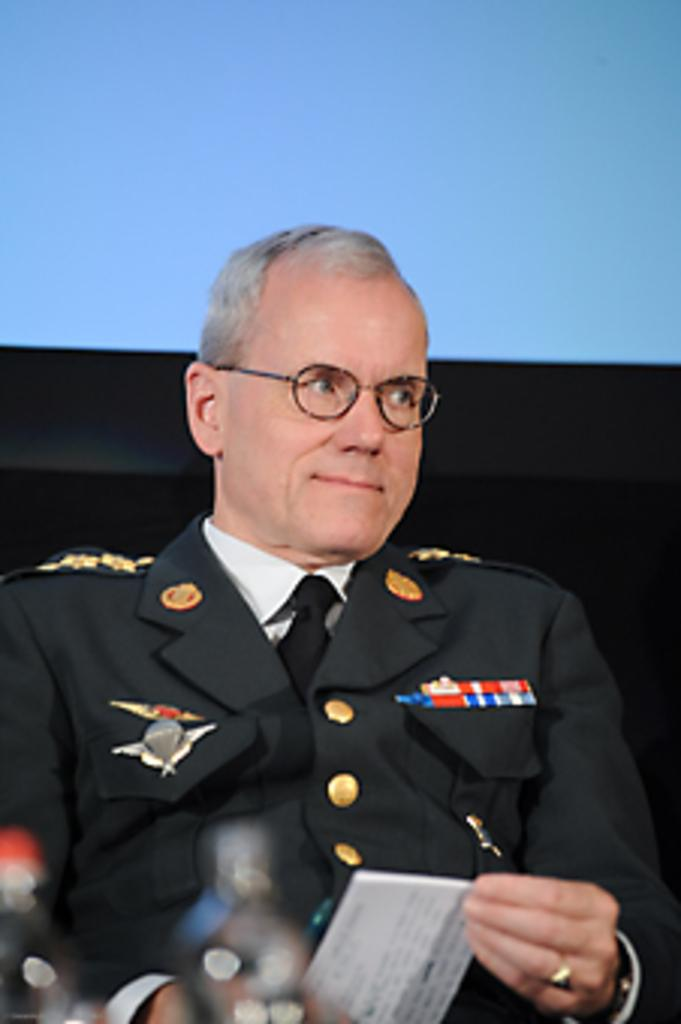What is the main subject of the image? There is a person in the image. What is the person wearing? The person is wearing a green jacket. What is the person holding? The person is holding a paper. What accessory is the person wearing? The person is wearing spectacles. What color can be seen in the background of the image? There is a blue color visible in the background. How many frogs are sitting on the person's head in the image? There are no frogs present in the image. What type of cover is protecting the person from the volcano in the image? There is no volcano or cover present in the image. 